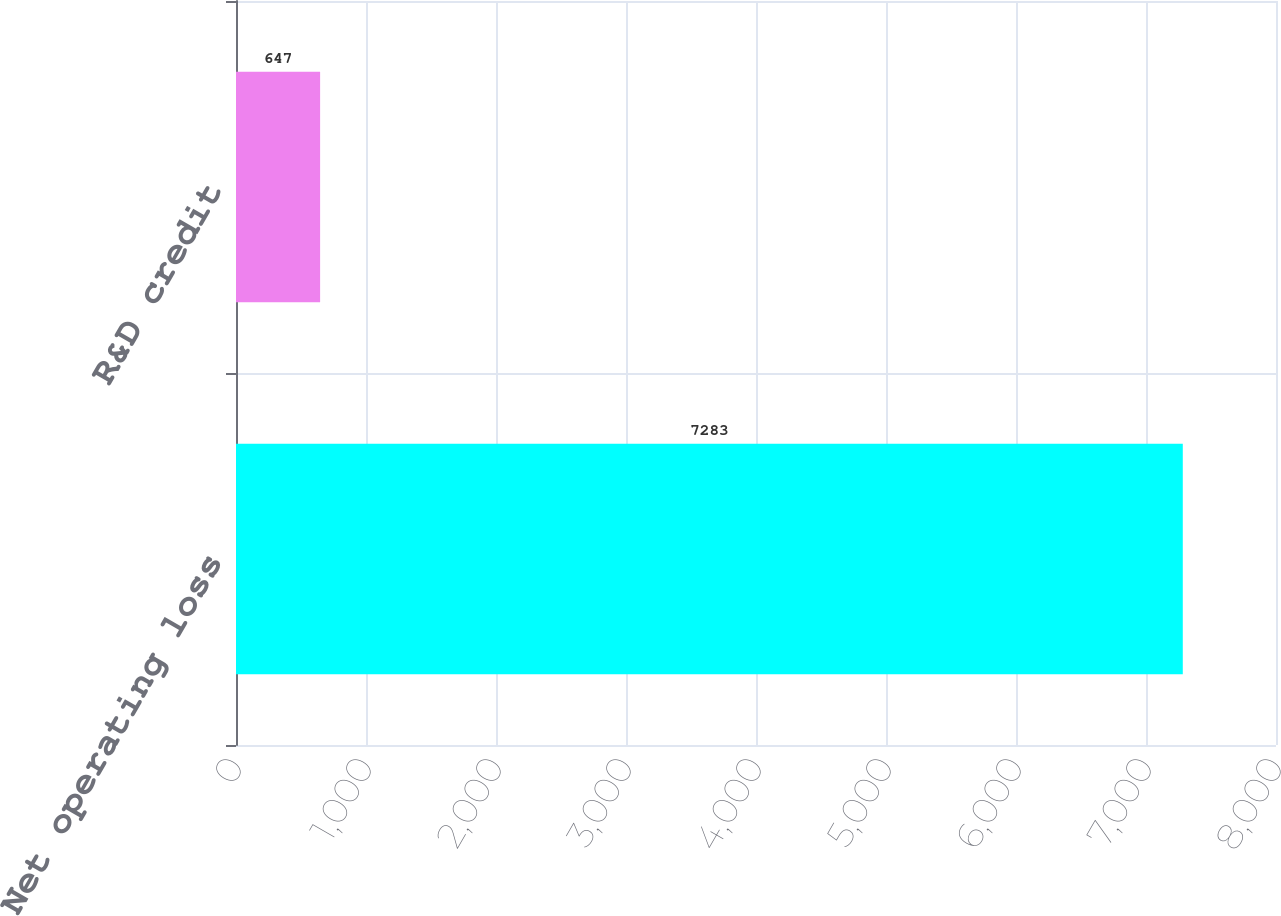<chart> <loc_0><loc_0><loc_500><loc_500><bar_chart><fcel>Net operating loss<fcel>R&D credit<nl><fcel>7283<fcel>647<nl></chart> 